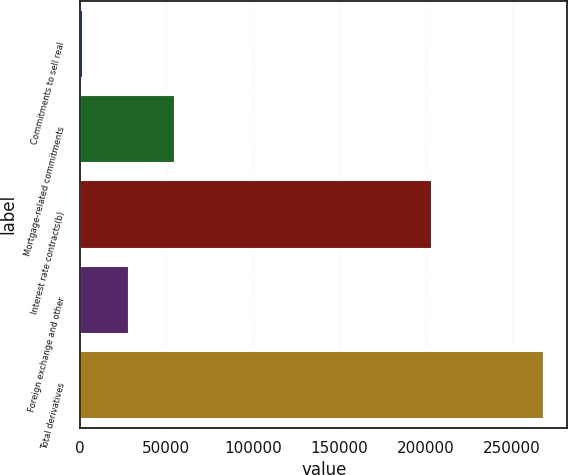Convert chart to OTSL. <chart><loc_0><loc_0><loc_500><loc_500><bar_chart><fcel>Commitments to sell real<fcel>Mortgage-related commitments<fcel>Interest rate contracts(b)<fcel>Foreign exchange and other<fcel>Total derivatives<nl><fcel>1844<fcel>55202.6<fcel>203517<fcel>28523.3<fcel>268637<nl></chart> 